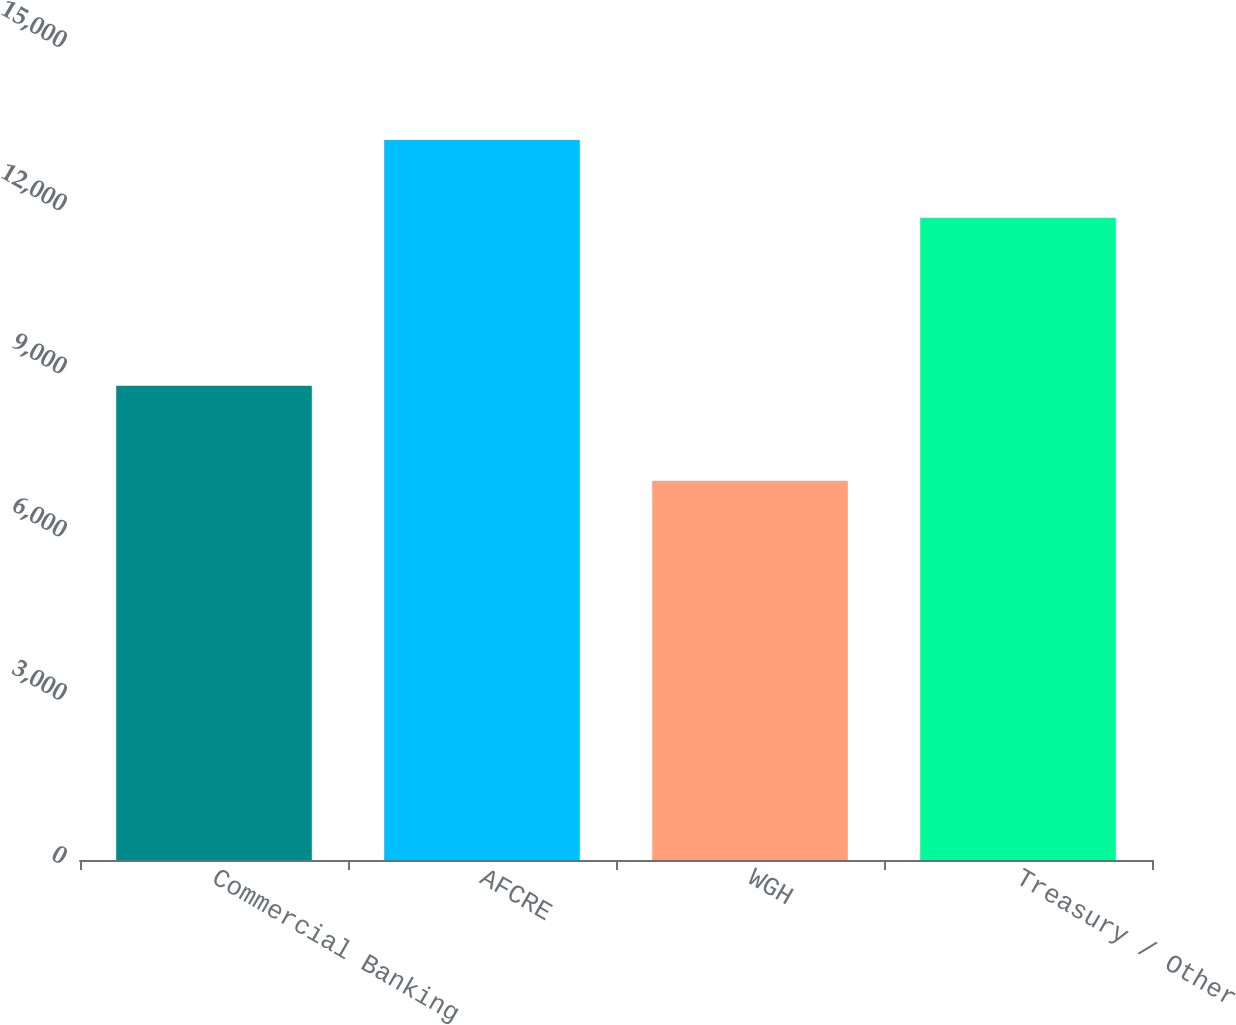<chart> <loc_0><loc_0><loc_500><loc_500><bar_chart><fcel>Commercial Banking<fcel>AFCRE<fcel>WGH<fcel>Treasury / Other<nl><fcel>8720<fcel>13233<fcel>6971<fcel>11808<nl></chart> 